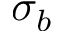<formula> <loc_0><loc_0><loc_500><loc_500>\sigma _ { b }</formula> 